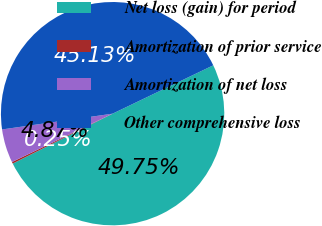Convert chart. <chart><loc_0><loc_0><loc_500><loc_500><pie_chart><fcel>Net loss (gain) for period<fcel>Amortization of prior service<fcel>Amortization of net loss<fcel>Other comprehensive loss<nl><fcel>49.75%<fcel>0.25%<fcel>4.87%<fcel>45.13%<nl></chart> 